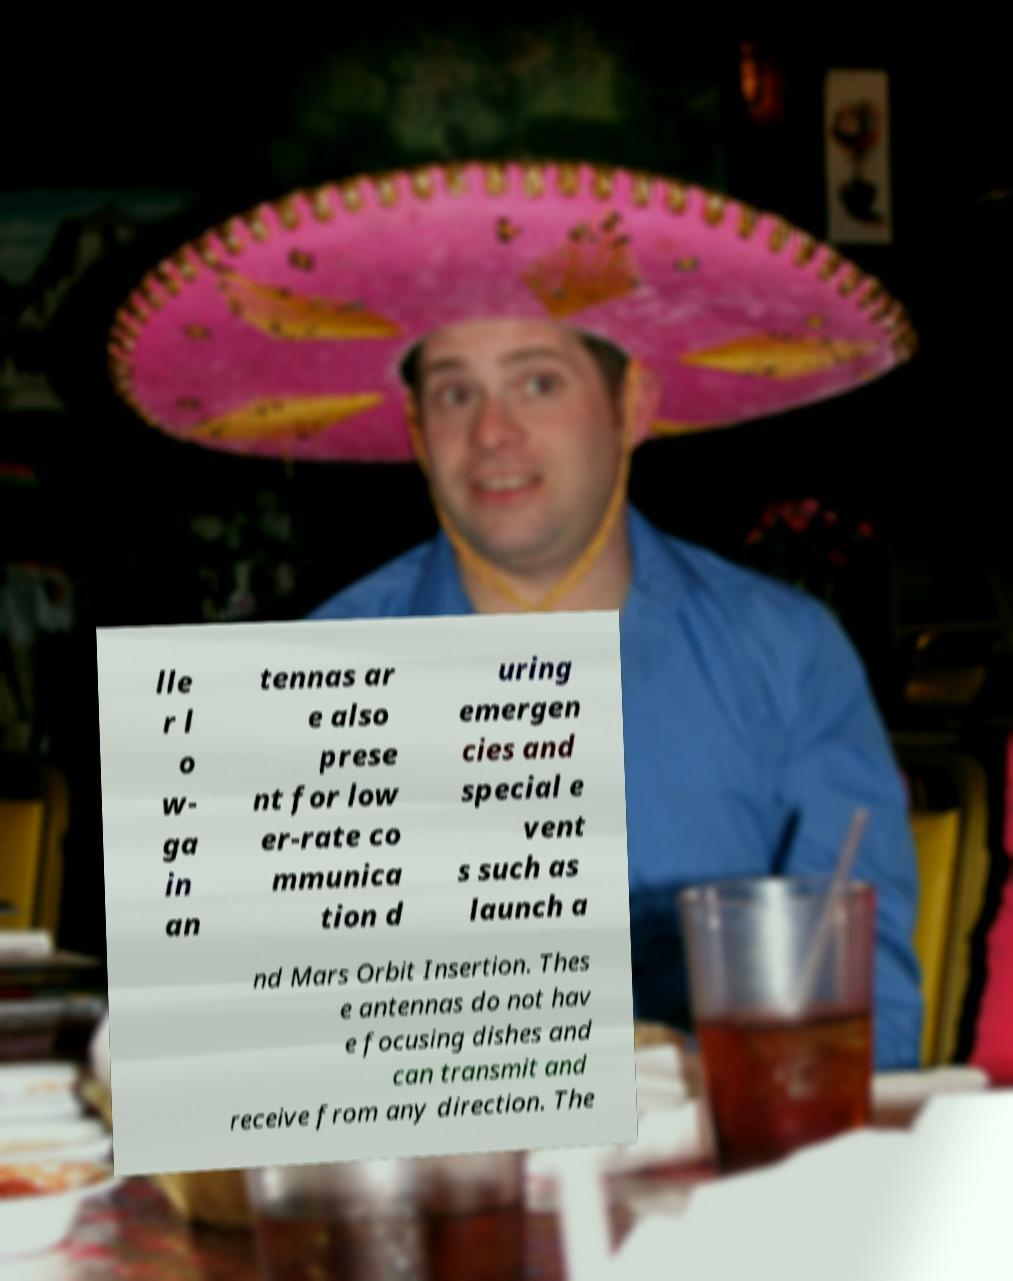Can you accurately transcribe the text from the provided image for me? lle r l o w- ga in an tennas ar e also prese nt for low er-rate co mmunica tion d uring emergen cies and special e vent s such as launch a nd Mars Orbit Insertion. Thes e antennas do not hav e focusing dishes and can transmit and receive from any direction. The 